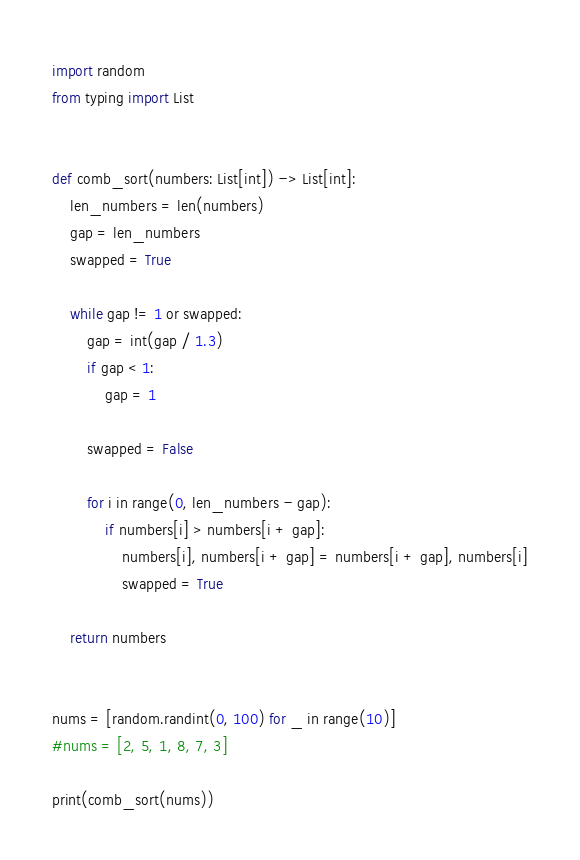<code> <loc_0><loc_0><loc_500><loc_500><_Python_>import random
from typing import List


def comb_sort(numbers: List[int]) -> List[int]:
    len_numbers = len(numbers)
    gap = len_numbers
    swapped = True

    while gap != 1 or swapped:
        gap = int(gap / 1.3)
        if gap < 1:
            gap = 1

        swapped = False

        for i in range(0, len_numbers - gap):
            if numbers[i] > numbers[i + gap]:
                numbers[i], numbers[i + gap] = numbers[i + gap], numbers[i]
                swapped = True

    return numbers


nums = [random.randint(0, 100) for _ in range(10)]
#nums = [2, 5, 1, 8, 7, 3]

print(comb_sort(nums))
</code> 